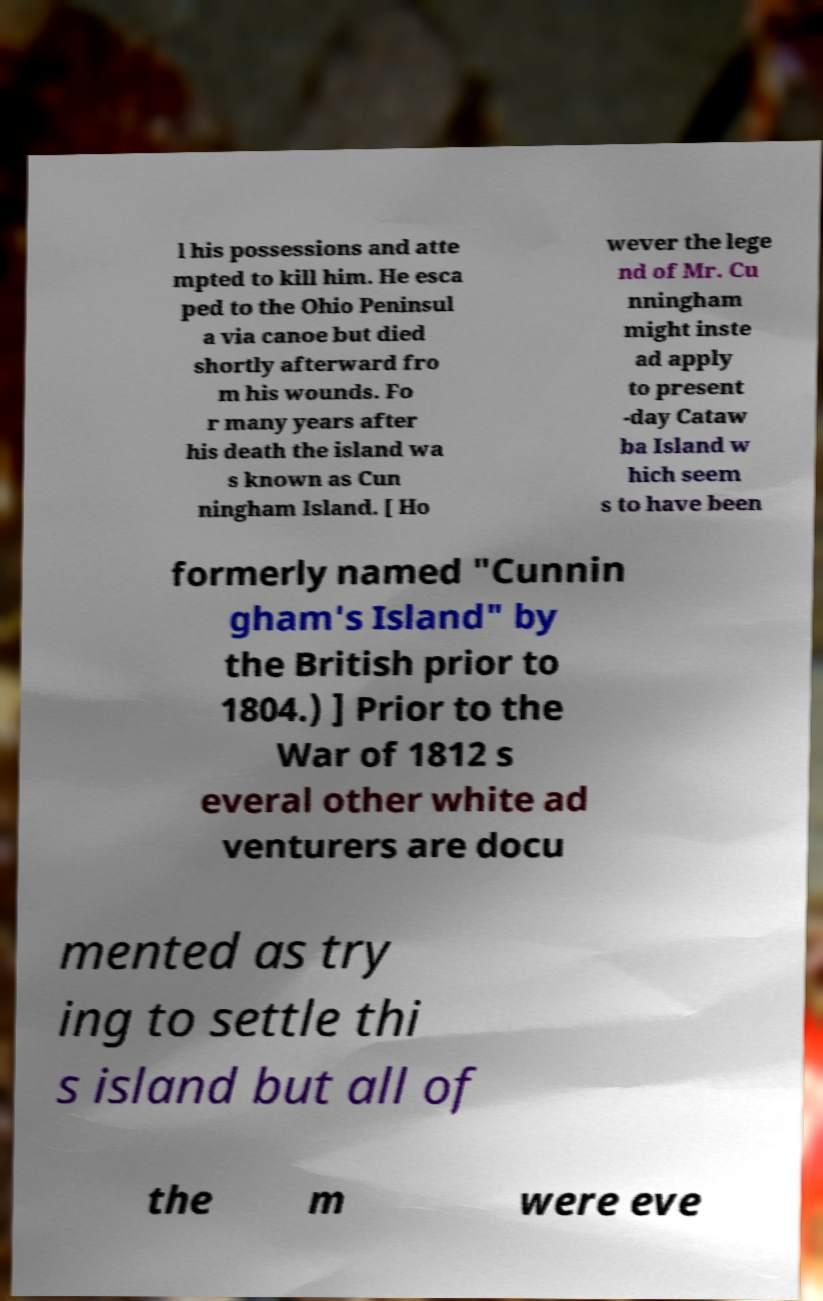What messages or text are displayed in this image? I need them in a readable, typed format. l his possessions and atte mpted to kill him. He esca ped to the Ohio Peninsul a via canoe but died shortly afterward fro m his wounds. Fo r many years after his death the island wa s known as Cun ningham Island. [ Ho wever the lege nd of Mr. Cu nningham might inste ad apply to present -day Cataw ba Island w hich seem s to have been formerly named "Cunnin gham's Island" by the British prior to 1804.) ] Prior to the War of 1812 s everal other white ad venturers are docu mented as try ing to settle thi s island but all of the m were eve 